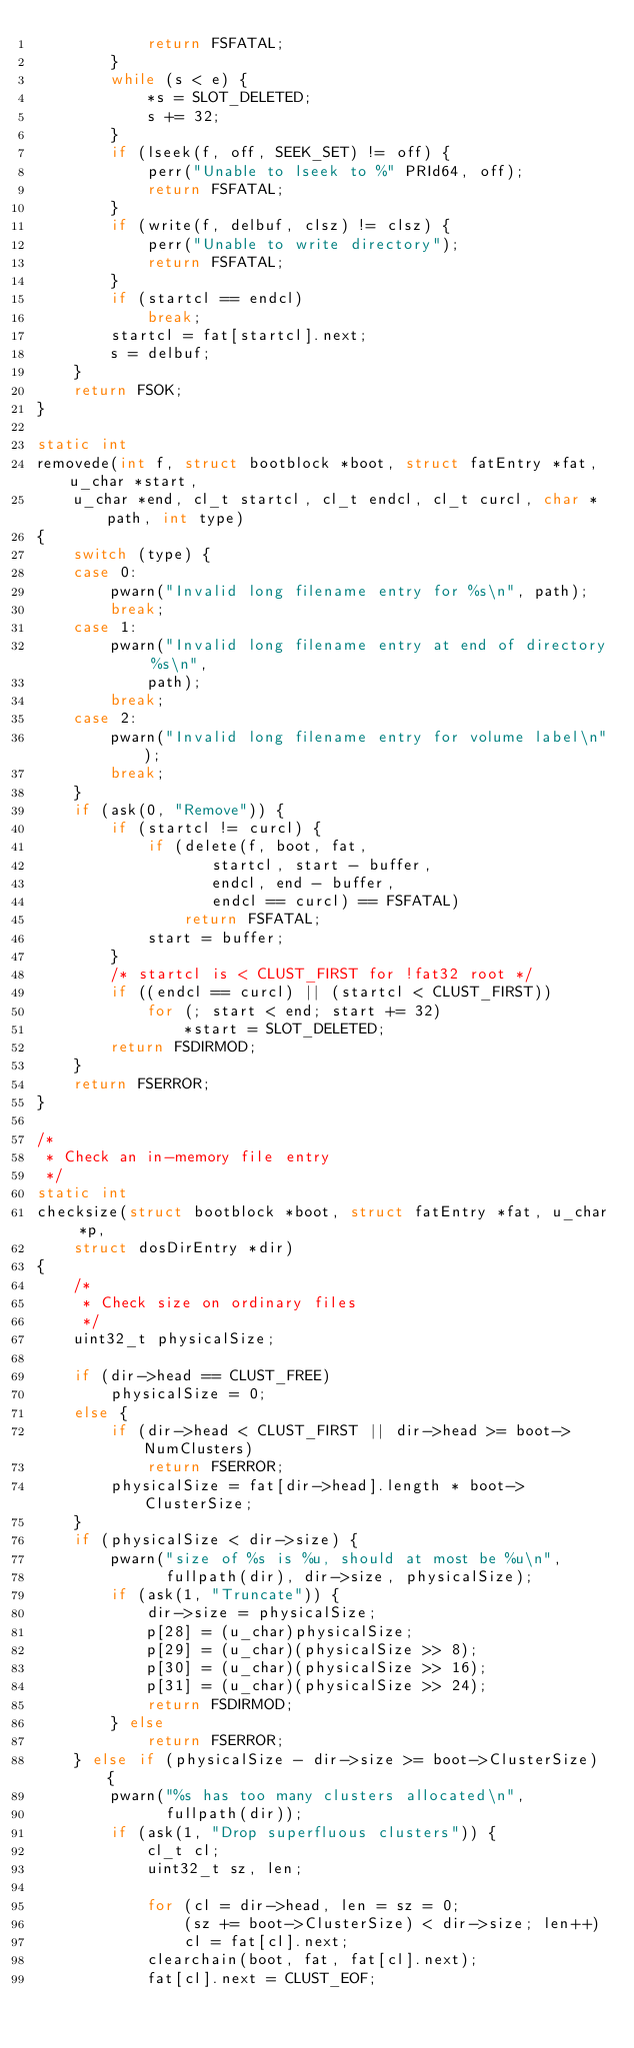Convert code to text. <code><loc_0><loc_0><loc_500><loc_500><_C_>			return FSFATAL;
		}
		while (s < e) {
			*s = SLOT_DELETED;
			s += 32;
		}
		if (lseek(f, off, SEEK_SET) != off) {
			perr("Unable to lseek to %" PRId64, off);
			return FSFATAL;
		}
		if (write(f, delbuf, clsz) != clsz) {
			perr("Unable to write directory");
			return FSFATAL;
		}
		if (startcl == endcl)
			break;
		startcl = fat[startcl].next;
		s = delbuf;
	}
	return FSOK;
}

static int
removede(int f, struct bootblock *boot, struct fatEntry *fat, u_char *start,
    u_char *end, cl_t startcl, cl_t endcl, cl_t curcl, char *path, int type)
{
	switch (type) {
	case 0:
		pwarn("Invalid long filename entry for %s\n", path);
		break;
	case 1:
		pwarn("Invalid long filename entry at end of directory %s\n",
		    path);
		break;
	case 2:
		pwarn("Invalid long filename entry for volume label\n");
		break;
	}
	if (ask(0, "Remove")) {
		if (startcl != curcl) {
			if (delete(f, boot, fat,
				   startcl, start - buffer,
				   endcl, end - buffer,
				   endcl == curcl) == FSFATAL)
				return FSFATAL;
			start = buffer;
		}
		/* startcl is < CLUST_FIRST for !fat32 root */
		if ((endcl == curcl) || (startcl < CLUST_FIRST))
			for (; start < end; start += 32)
				*start = SLOT_DELETED;
		return FSDIRMOD;
	}
	return FSERROR;
}

/*
 * Check an in-memory file entry
 */
static int
checksize(struct bootblock *boot, struct fatEntry *fat, u_char *p,
    struct dosDirEntry *dir)
{
	/*
	 * Check size on ordinary files
	 */
	uint32_t physicalSize;

	if (dir->head == CLUST_FREE)
		physicalSize = 0;
	else {
		if (dir->head < CLUST_FIRST || dir->head >= boot->NumClusters)
			return FSERROR;
		physicalSize = fat[dir->head].length * boot->ClusterSize;
	}
	if (physicalSize < dir->size) {
		pwarn("size of %s is %u, should at most be %u\n",
		      fullpath(dir), dir->size, physicalSize);
		if (ask(1, "Truncate")) {
			dir->size = physicalSize;
			p[28] = (u_char)physicalSize;
			p[29] = (u_char)(physicalSize >> 8);
			p[30] = (u_char)(physicalSize >> 16);
			p[31] = (u_char)(physicalSize >> 24);
			return FSDIRMOD;
		} else
			return FSERROR;
	} else if (physicalSize - dir->size >= boot->ClusterSize) {
		pwarn("%s has too many clusters allocated\n",
		      fullpath(dir));
		if (ask(1, "Drop superfluous clusters")) {
			cl_t cl;
			uint32_t sz, len;

			for (cl = dir->head, len = sz = 0;
			    (sz += boot->ClusterSize) < dir->size; len++)
				cl = fat[cl].next;
			clearchain(boot, fat, fat[cl].next);
			fat[cl].next = CLUST_EOF;</code> 